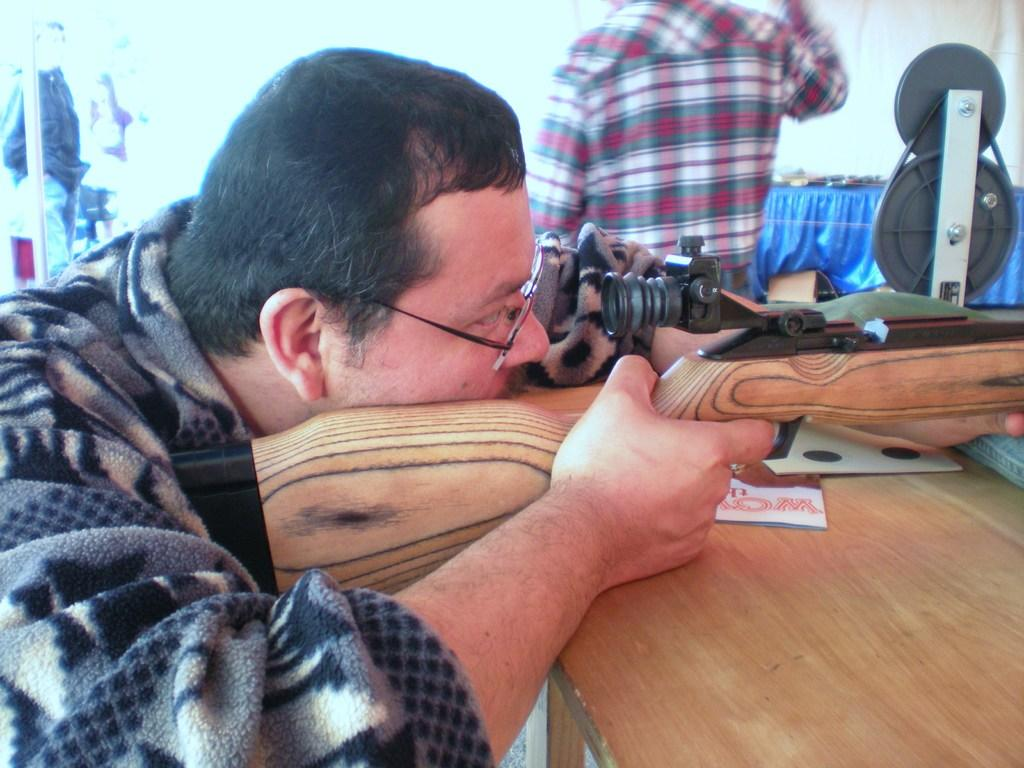What is the man in the image holding? The man is holding a gun in the image. What is the man doing with the gun? The man is aiming the gun at something. Can you describe the other person in the image? There is a person standing in the image. How old is the baby in the image? There is no baby present in the image; it only features a man holding a gun and another person standing nearby. 